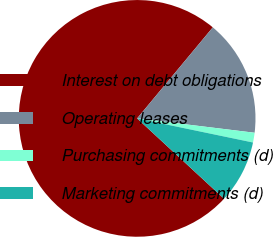Convert chart. <chart><loc_0><loc_0><loc_500><loc_500><pie_chart><fcel>Interest on debt obligations<fcel>Operating leases<fcel>Purchasing commitments (d)<fcel>Marketing commitments (d)<nl><fcel>74.16%<fcel>15.9%<fcel>1.33%<fcel>8.61%<nl></chart> 